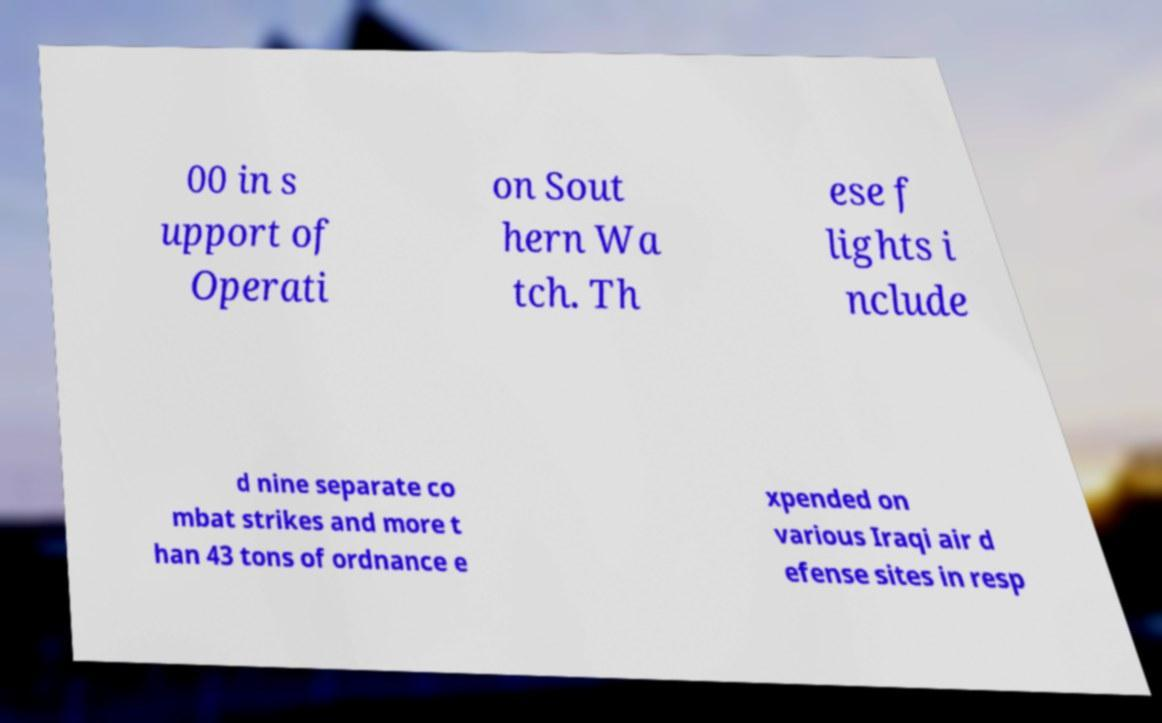Can you accurately transcribe the text from the provided image for me? 00 in s upport of Operati on Sout hern Wa tch. Th ese f lights i nclude d nine separate co mbat strikes and more t han 43 tons of ordnance e xpended on various Iraqi air d efense sites in resp 